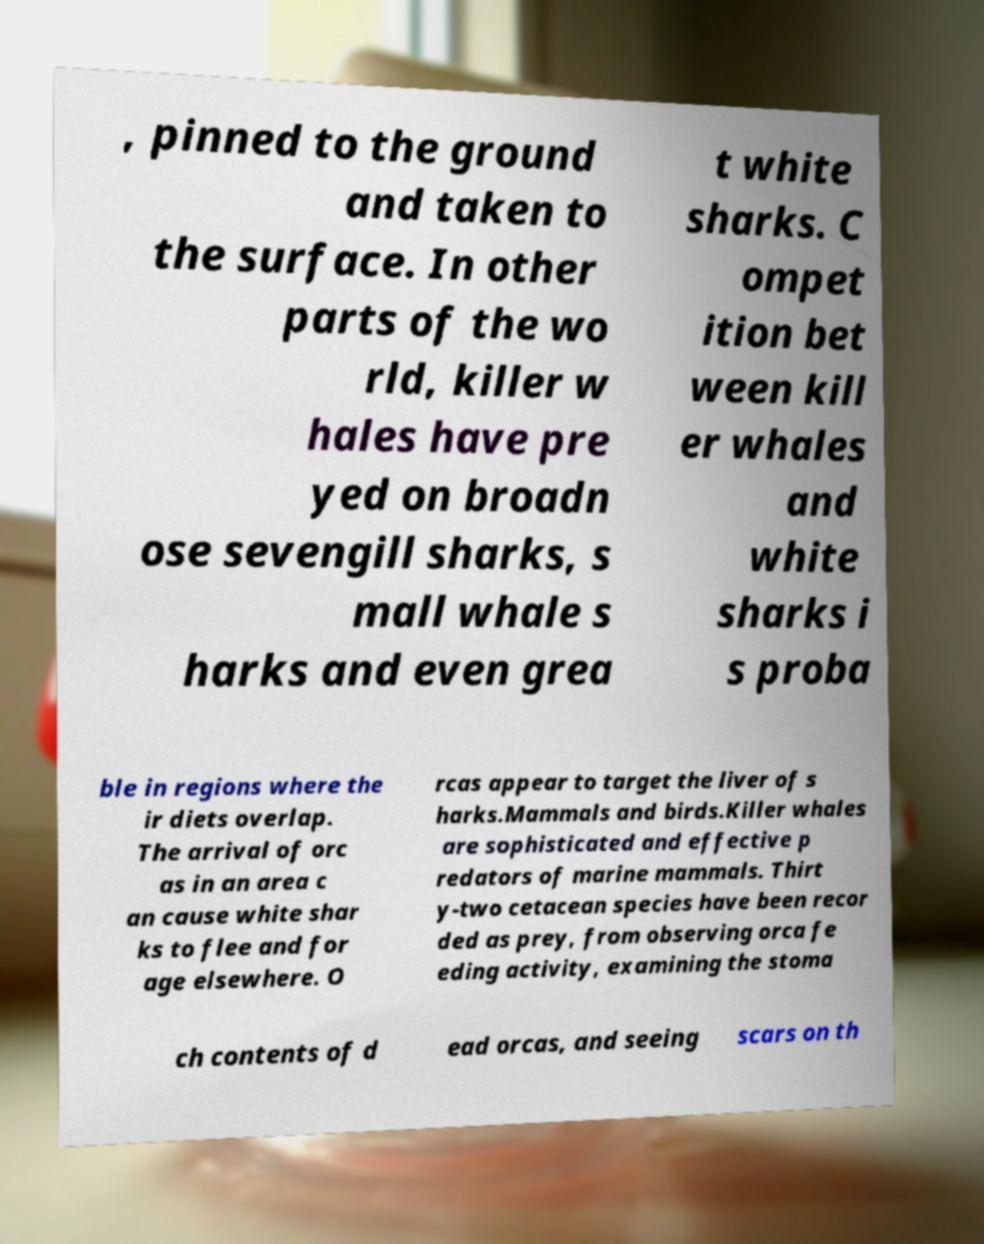What messages or text are displayed in this image? I need them in a readable, typed format. , pinned to the ground and taken to the surface. In other parts of the wo rld, killer w hales have pre yed on broadn ose sevengill sharks, s mall whale s harks and even grea t white sharks. C ompet ition bet ween kill er whales and white sharks i s proba ble in regions where the ir diets overlap. The arrival of orc as in an area c an cause white shar ks to flee and for age elsewhere. O rcas appear to target the liver of s harks.Mammals and birds.Killer whales are sophisticated and effective p redators of marine mammals. Thirt y-two cetacean species have been recor ded as prey, from observing orca fe eding activity, examining the stoma ch contents of d ead orcas, and seeing scars on th 